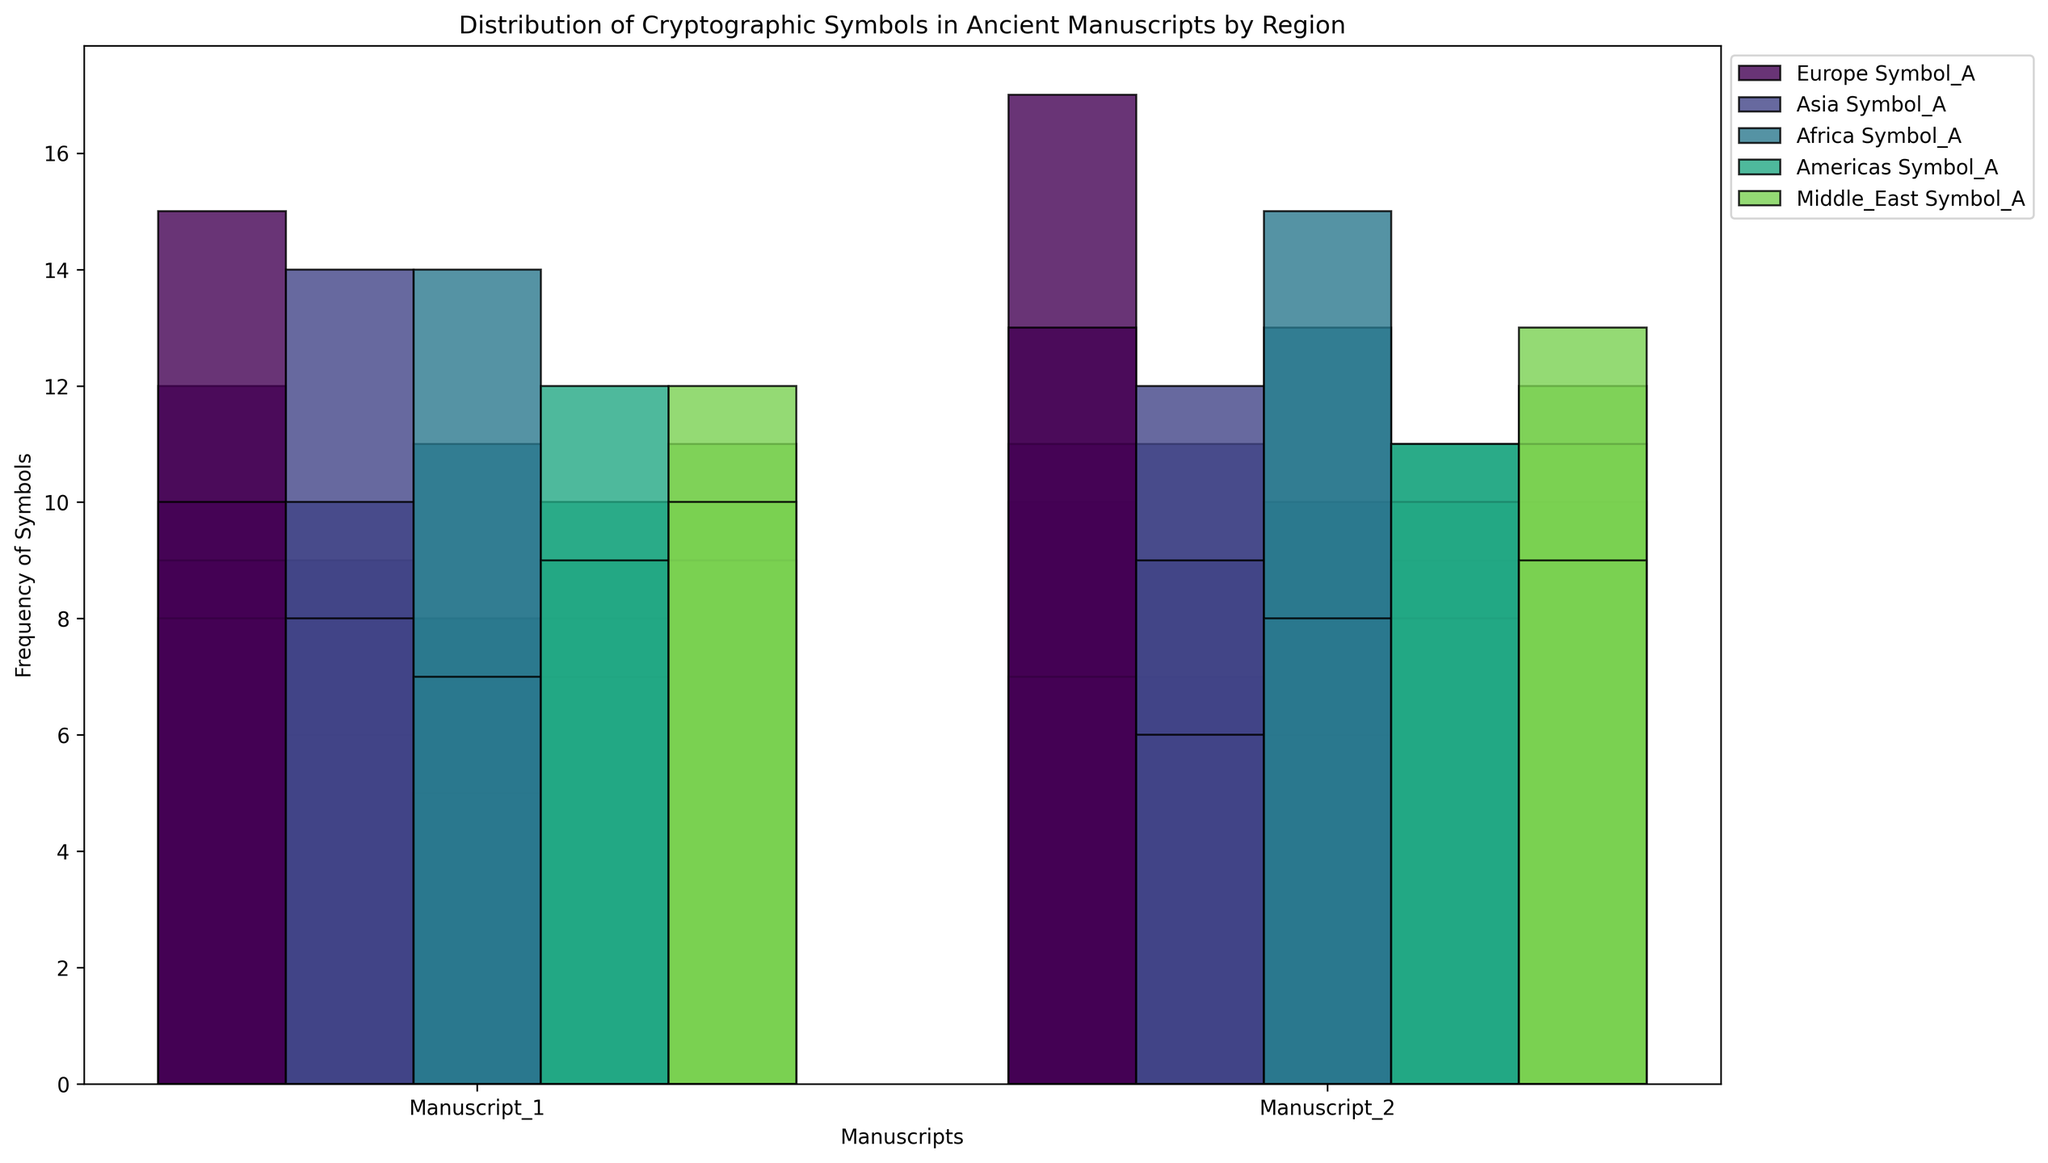What is the total number of Symbol_A occurrences in European manuscripts? Identify the values of Symbol_A in Europe (12 and 10) and sum them: 12 + 10 = 22
Answer: 22 Which region has the maximum occurrences of Symbol_C in its manuscripts? Look at the heights of the bars for Symbol_C and note the maximum values: Asia (14 and 12). Thus, Asia has the highest occurrences of Symbol_C
Answer: Asia What is the difference in the frequency of Symbol_D between the Middle East Manuscript_1 and Africa Manuscript_2? Identify Symbol_D values for Middle East Manuscript_1 (12) and Africa Manuscript_2 (15). Calculate the difference: 15 - 12 = 3
Answer: 3 In which region does Symbol_E appear most frequently? Observe the heights of the Symbol_E bars across all regions and find the maximum frequency: Europe (13), Americas (11), Middle East (10), Africa (8), Asia (8). The highest is in Europe
Answer: Europe Which manuscript and symbol have the highest overall frequency in the Americas? Compare the bars within the Americas' manuscripts for each symbol: Symbol_D (12 in Manuscript_1) and Symbol_E (11 in Manuscript_2). The highest frequency is 12 for Symbol_D in Manuscript_1
Answer: Manuscript_1, Symbol_D How do the occurrences of Symbol_B in African manuscripts compare to Symbol_B in Asian manuscripts? Observe the frequencies of Symbol_B in Africa (8 and 10) and Asia (9 and 11). Sum the frequencies: Africa: 8 + 10 = 18, Asia: 9 + 11 = 20
Answer: Asia has more What's the average frequency of Symbol_A across all regions? Sum the Symbol_A frequencies for all regions: Europe (12+10), Asia (6+7), Africa (5+6), Americas (8+9), Middle East (11+10). Total: 12+10+6+7+5+6+8+9+11+10=84, then divide by the number of entries (10): 84 / 10 = 8.4
Answer: 8.4 Which symbol has the lowest average frequency across all regions? Calculate the average frequencies for each symbol (sum of occurrences divided by number of entries): Symbol_A (84/10), Symbol_B (108/10), Symbol_C (108/10), Symbol_D (110/10), Symbol_E (91/10). The lowest ratio is Symbol_A
Answer: Symbol_A Between Manuscript_1 and Manuscript_2 in the Middle East, which symbol showed the greatest increase in frequency? Compare the symbol frequencies for Manuscript_1 and Manuscript_2: Symbol_A: 11 to 10 (-1), Symbol_B: 10 to 12 (+2), Symbol_C: 9 to 11 (+2), Symbol_D: 12 to 13 (+1), Symbol_E: 10 to 9 (-1). The greatest increase is in Symbol_B and Symbol_C (both +2)
Answer: Symbol_B, Symbol_C What is the total number of symbols counted in the Asian manuscripts? Sum all occurrences of the symbols in Asia: Manuscript_1 (6+9+14+10+8) and Manuscript_2 (7+11+12+9+6). Total: 6+9+14+10+8+7+11+12+9+6 = 92
Answer: 92 